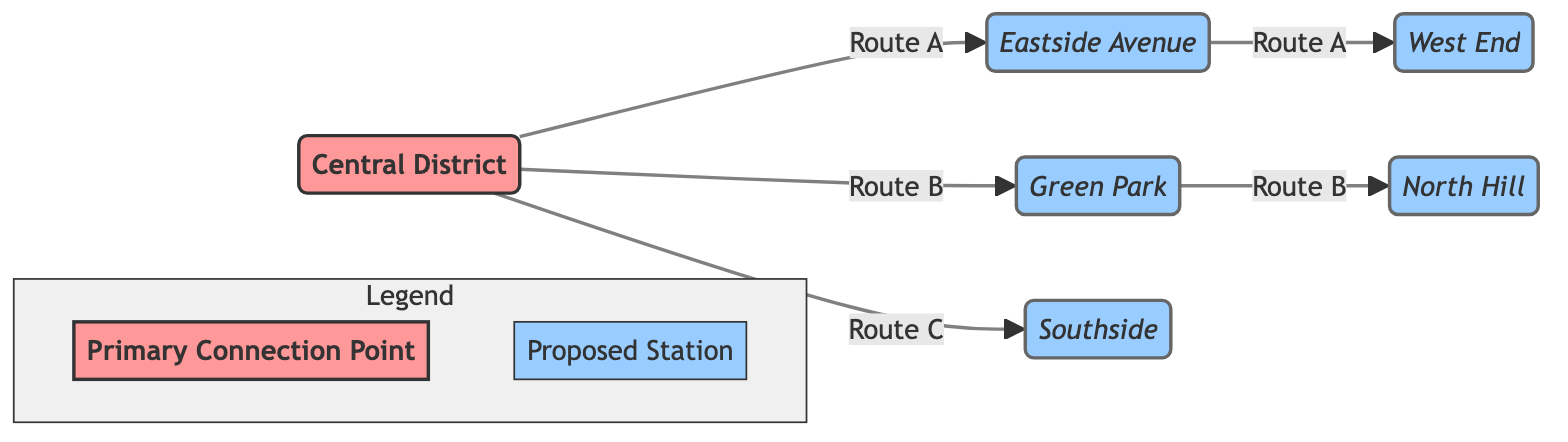What is the central hub in the diagram? The diagram identifies "Central District" as the primary hub where various routes converge. It is labeled distinctly with a specific style indicating its significance as a connection point.
Answer: Central District How many proposed stations are indicated in the diagram? The diagram shows a total of five proposed stations: "Eastside Avenue," "West End," "Green Park," "North Hill," and "Southside." By counting these individually, we can confirm there are five stations total.
Answer: 5 What routes connect to "Green Park"? Examining the diagram, "Green Park" is connected by "Route B" which leads there from "Central District." This route does not link directly to any other stations in the diagram.
Answer: Route B Which station does "Route C" lead to directly? In the diagram, "Route C" connects "Central District" to "Southside," creating a direct route. There are no other stations in-between, making "Southside" the endpoint of this route.
Answer: Southside What is the relationship between "North Hill" and "Central District"? "North Hill" is connected to "Green Park" through "Route B," and "Green Park" is linked directly to "Central District." Therefore, "North Hill" is indirectly connected to "Central District" through "Green Park."
Answer: Indirect connection How many routes start from the "Central District"? Analyzing the diagram, there are three distinct routes emanating from "Central District": "Route A," "Route B," and "Route C." By identifying these routes, we conclude there are three originating routes.
Answer: 3 What color represents the proposed stations? The proposed stations in the diagram are represented in a light blue color, specifically denoted by the class style as "fill:#99ccff." This visual representation helps distinguish them from other elements.
Answer: Light blue What type of connection does the "Legend" illustrate? The "Legend" in the diagram elucidates the types of connection points, defining "Primary Connection Point" for the hub and "Proposed Station" for the newly suggested stops in the transportation plan.
Answer: Connection types Which station is on the route that connects to both "Eastside Avenue" and "West End"? "Route A" facilitates a connection that includes both "Eastside Avenue" and "West End," indicating that these two stations are sequentially linked through this route.
Answer: Route A 